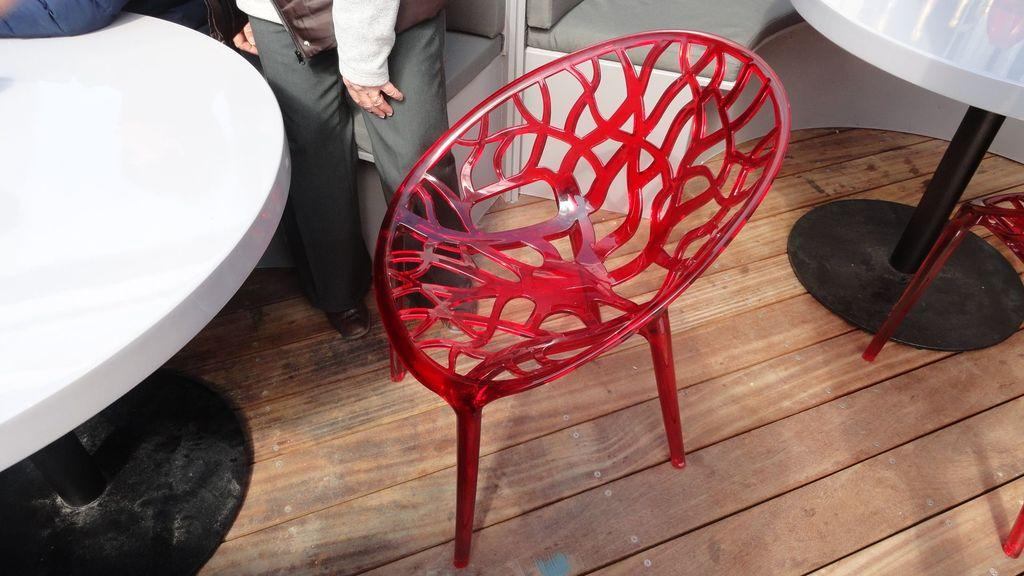What type of furniture is present in the image? There are chairs and a table in the image. What is the material of the floor in the image? The floor is made of wood. Are there any people visible in the image? Yes, there are two persons standing in the background. What position do the girls hold in the image? There are no girls present in the image. Is there a van visible in the image? No, there is no van present in the image. 